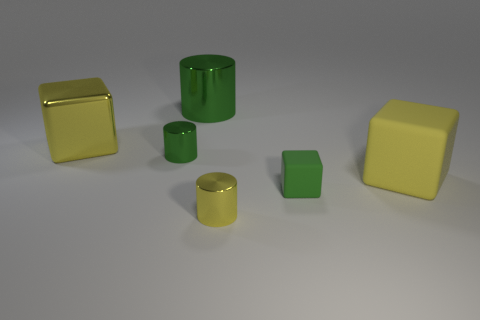There is a yellow metallic object that is to the right of the small object that is left of the tiny yellow thing; are there any small things that are behind it?
Make the answer very short. Yes. What is the color of the tiny rubber thing?
Ensure brevity in your answer.  Green. There is a metallic cube that is the same size as the yellow rubber cube; what color is it?
Keep it short and to the point. Yellow. There is a small metallic thing in front of the tiny rubber object; does it have the same shape as the green rubber thing?
Make the answer very short. No. There is a metal object right of the green thing behind the big yellow cube on the left side of the tiny yellow metallic cylinder; what is its color?
Your answer should be very brief. Yellow. Is there a gray sphere?
Offer a very short reply. No. How many other objects are there of the same size as the yellow metallic cylinder?
Ensure brevity in your answer.  2. There is a tiny matte object; does it have the same color as the small shiny cylinder in front of the big yellow matte object?
Provide a short and direct response. No. What number of objects are either large metallic blocks or large rubber blocks?
Give a very brief answer. 2. Do the yellow cylinder and the large cube that is in front of the yellow shiny block have the same material?
Make the answer very short. No. 